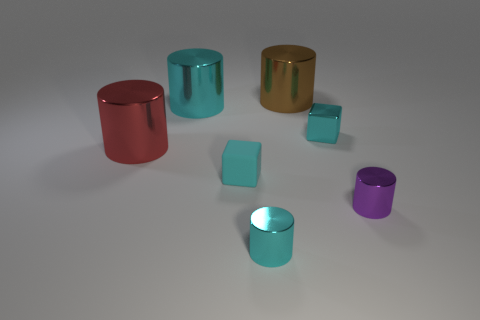What number of small cyan metal cubes are there?
Your answer should be compact. 1. The small cyan thing that is on the right side of the tiny cyan shiny object to the left of the brown thing is what shape?
Make the answer very short. Cube. How many cyan objects are in front of the large cyan metal cylinder?
Make the answer very short. 3. Are the big brown cylinder and the small block that is left of the big brown metal cylinder made of the same material?
Provide a short and direct response. No. Is there a purple cylinder of the same size as the rubber block?
Your answer should be compact. Yes. Are there an equal number of red cylinders that are on the left side of the big red thing and tiny cyan metallic blocks?
Make the answer very short. No. How big is the shiny cube?
Offer a terse response. Small. There is a cyan block right of the brown shiny thing; what number of cyan cylinders are in front of it?
Ensure brevity in your answer.  1. What shape is the big object that is in front of the big brown metallic cylinder and right of the big red shiny object?
Make the answer very short. Cylinder. How many small metallic things have the same color as the rubber thing?
Keep it short and to the point. 2. 